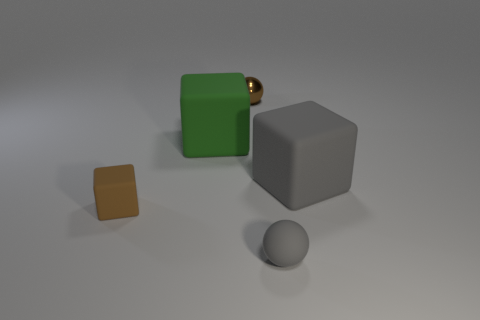Subtract all green cubes. How many cubes are left? 2 Subtract 1 cubes. How many cubes are left? 2 Add 4 gray balls. How many objects exist? 9 Subtract all cubes. How many objects are left? 2 Add 5 small gray rubber objects. How many small gray rubber objects are left? 6 Add 4 small things. How many small things exist? 7 Subtract 0 blue blocks. How many objects are left? 5 Subtract all cyan spheres. Subtract all green things. How many objects are left? 4 